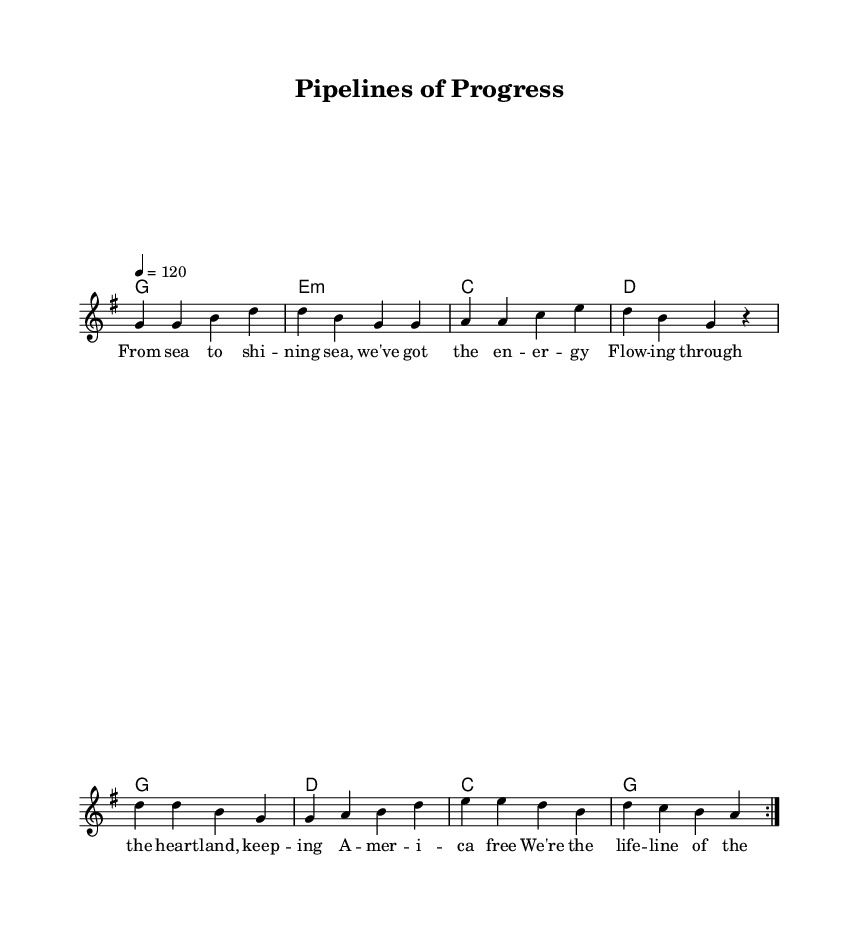what is the key signature of this music? The key signature indicated is G major, which has one sharp (F#). This can be determined by the key signature shown at the beginning of the staff.
Answer: G major what is the time signature of this music? The time signature is 4/4, which indicates that there are four beats in each measure and the quarter note gets one beat. This is visible at the start of the sheet music.
Answer: 4/4 what is the tempo marking of this music? The tempo marking is 120 beats per minute, which indicates a moderately fast pace for the song. This marking is found next to the note indicating the tempo.
Answer: 120 how many times is the melody repeated in the piece? The melody is repeated 2 times as denoted by the \repeat volta 2 in the melody section. This indicates that the preceding music should be played twice.
Answer: 2 which chord is played in the first measure? The first measure contains the G major chord, as indicated by the chord names listed above the staff. The chord is played as a whole note in the first bar.
Answer: G major what themes are presented in the lyrics of this song? The lyrics celebrate American infrastructure and energy management, emphasizing concepts such as freedom, being a lifeline, and strength. This is inferred from content about "energy," "infrastructure," and "stronger."
Answer: infrastructure how does this song exemplify the Country Rock genre? This song features characteristics typical of Country Rock, including a strong rhythmic backbone, straightforward melodies, and lyrics that reflect American themes like infrastructure. These aspects are evidenced in its structure and lyrical content.
Answer: American themes 